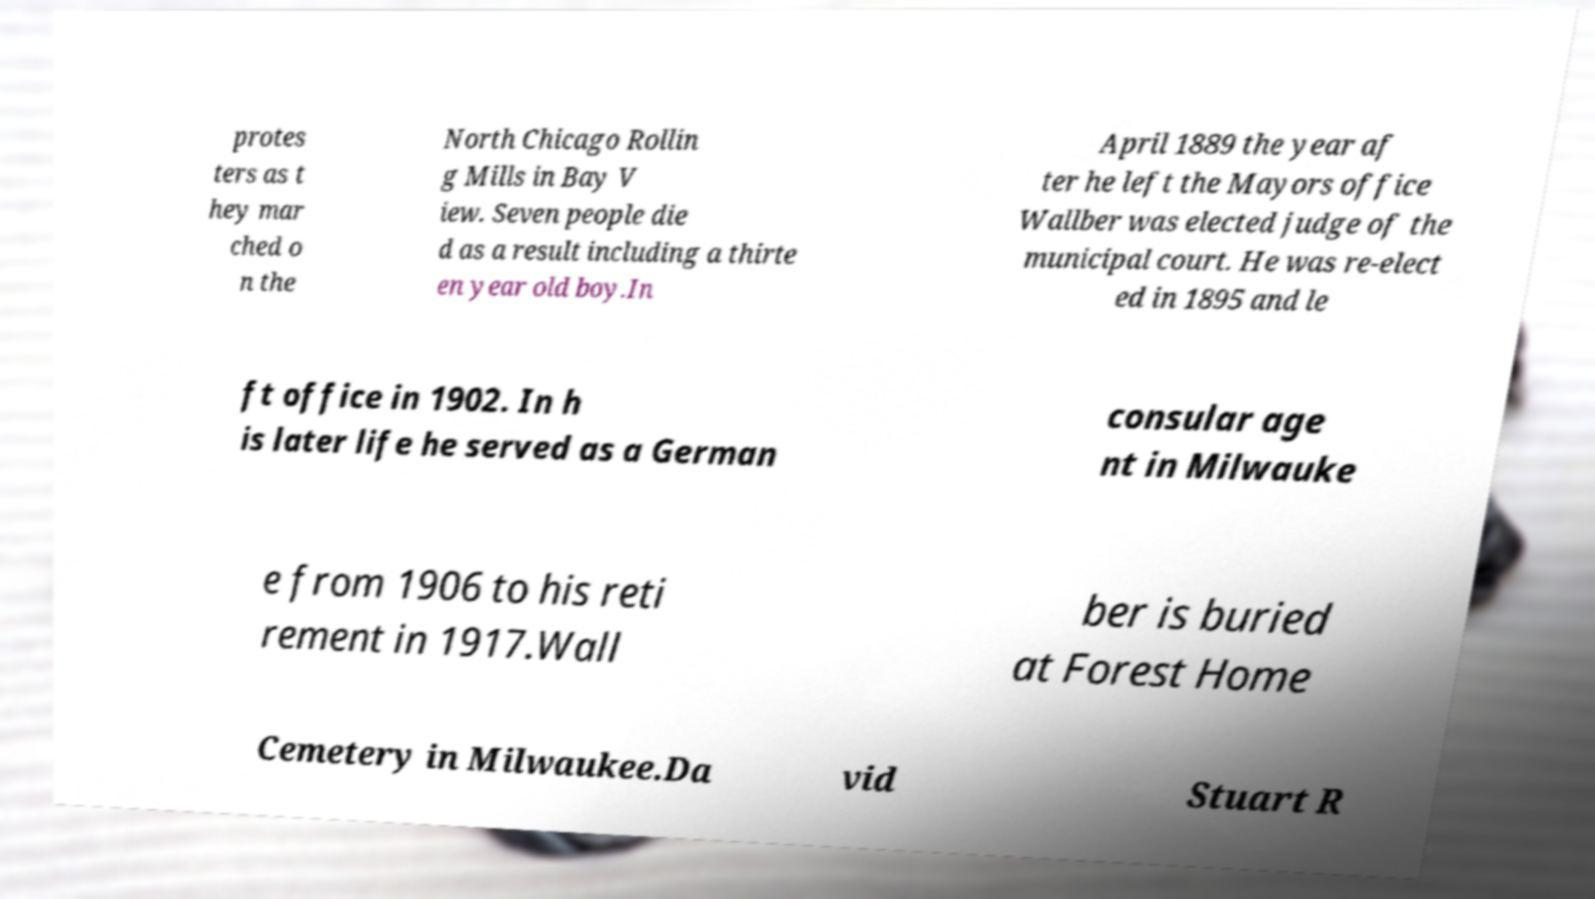Please read and relay the text visible in this image. What does it say? protes ters as t hey mar ched o n the North Chicago Rollin g Mills in Bay V iew. Seven people die d as a result including a thirte en year old boy.In April 1889 the year af ter he left the Mayors office Wallber was elected judge of the municipal court. He was re-elect ed in 1895 and le ft office in 1902. In h is later life he served as a German consular age nt in Milwauke e from 1906 to his reti rement in 1917.Wall ber is buried at Forest Home Cemetery in Milwaukee.Da vid Stuart R 